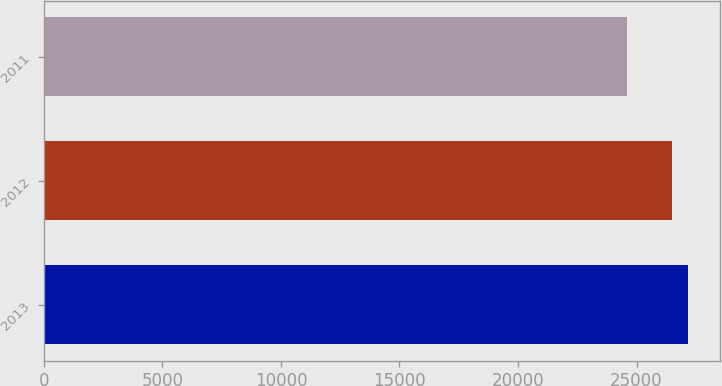Convert chart. <chart><loc_0><loc_0><loc_500><loc_500><bar_chart><fcel>2013<fcel>2012<fcel>2011<nl><fcel>27171<fcel>26515<fcel>24581<nl></chart> 